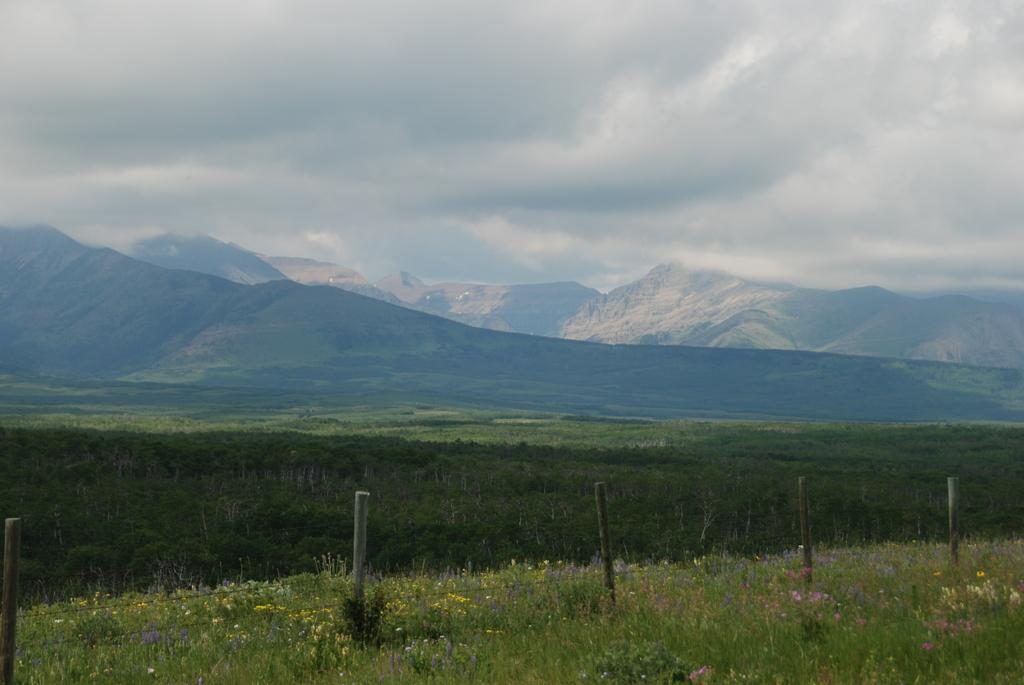What objects are on the ground in the image? There are poles on the ground in the image. What type of vegetation is present in the image? There are plants and grass in the image. What can be seen in the background of the image? There are hills and a sky visible in the background of the image. What is the condition of the sky in the image? Clouds are present in the sky. How many minutes does it take for the boat to pass by in the image? There is no boat present in the image, so it is not possible to determine how many minutes it would take for a boat to pass by. 